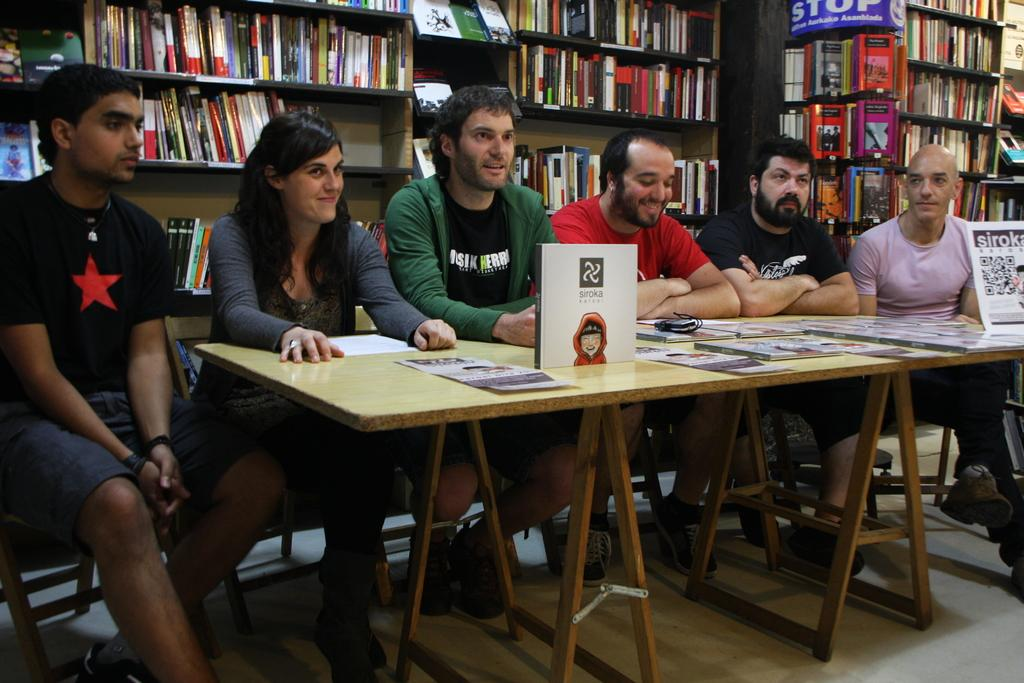What type of place is depicted in the image? The image is of a library. What can be seen on the shelves in the library? There are books in racks in the image. What are the people in the image doing? There are persons sitting on chairs in the image. Where are the chairs located in relation to the table? The chairs are in front of a table. What is on the table in the image? There are papers on the table. What is the floor like in the library? The image shows a floor. Can you see any fowl or volcanoes in the image? No, there are no fowl or volcanoes present in the image. What type of bushes can be seen growing near the library? There are no bushes visible in the image; it is set indoors in a library. 